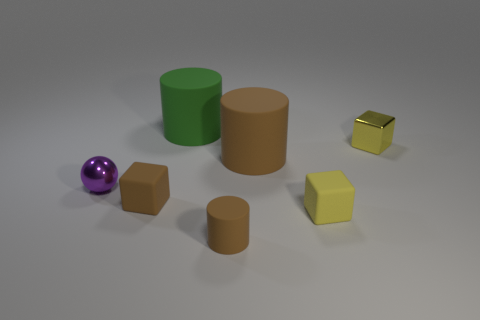How many things are tiny metal spheres or small brown rubber cylinders?
Your answer should be compact. 2. There is a matte cylinder in front of the ball; what is its color?
Provide a short and direct response. Brown. There is a brown thing that is the same shape as the yellow shiny object; what size is it?
Make the answer very short. Small. How many objects are either cylinders behind the ball or cylinders in front of the small yellow rubber cube?
Provide a short and direct response. 3. There is a block that is to the right of the green object and to the left of the tiny shiny cube; how big is it?
Your answer should be compact. Small. There is a green object; is it the same shape as the tiny yellow object that is behind the shiny ball?
Your answer should be compact. No. What number of objects are either small brown rubber cylinders that are in front of the shiny cube or large red objects?
Make the answer very short. 1. Are the sphere and the cube that is behind the big brown object made of the same material?
Your response must be concise. Yes. The large rubber thing on the right side of the matte cylinder behind the small yellow metallic thing is what shape?
Make the answer very short. Cylinder. There is a small cylinder; is it the same color as the big rubber cylinder in front of the shiny cube?
Your answer should be compact. Yes. 